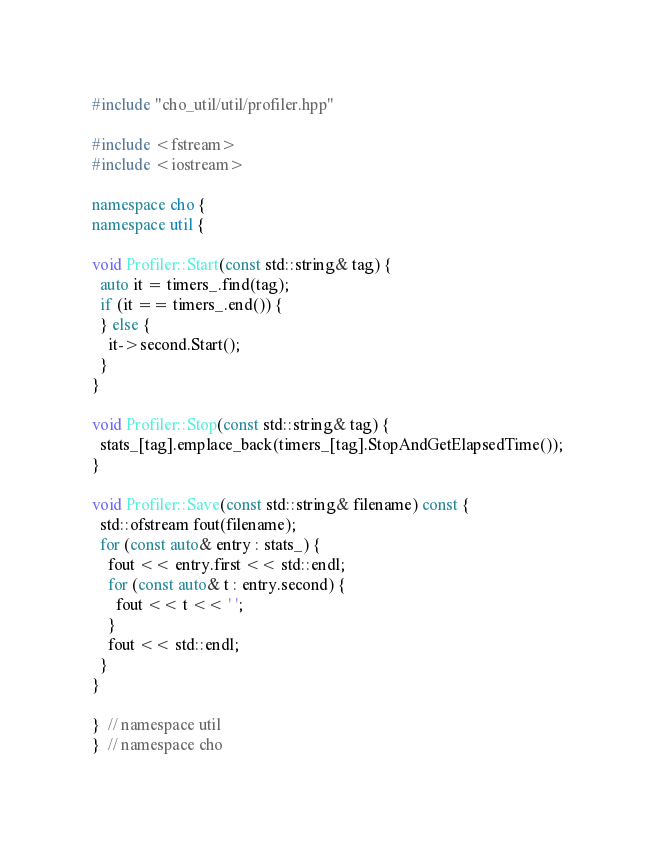Convert code to text. <code><loc_0><loc_0><loc_500><loc_500><_C++_>#include "cho_util/util/profiler.hpp"

#include <fstream>
#include <iostream>

namespace cho {
namespace util {

void Profiler::Start(const std::string& tag) {
  auto it = timers_.find(tag);
  if (it == timers_.end()) {
  } else {
    it->second.Start();
  }
}

void Profiler::Stop(const std::string& tag) {
  stats_[tag].emplace_back(timers_[tag].StopAndGetElapsedTime());
}

void Profiler::Save(const std::string& filename) const {
  std::ofstream fout(filename);
  for (const auto& entry : stats_) {
    fout << entry.first << std::endl;
    for (const auto& t : entry.second) {
      fout << t << ' ';
    }
    fout << std::endl;
  }
}

}  // namespace util
}  // namespace cho
</code> 